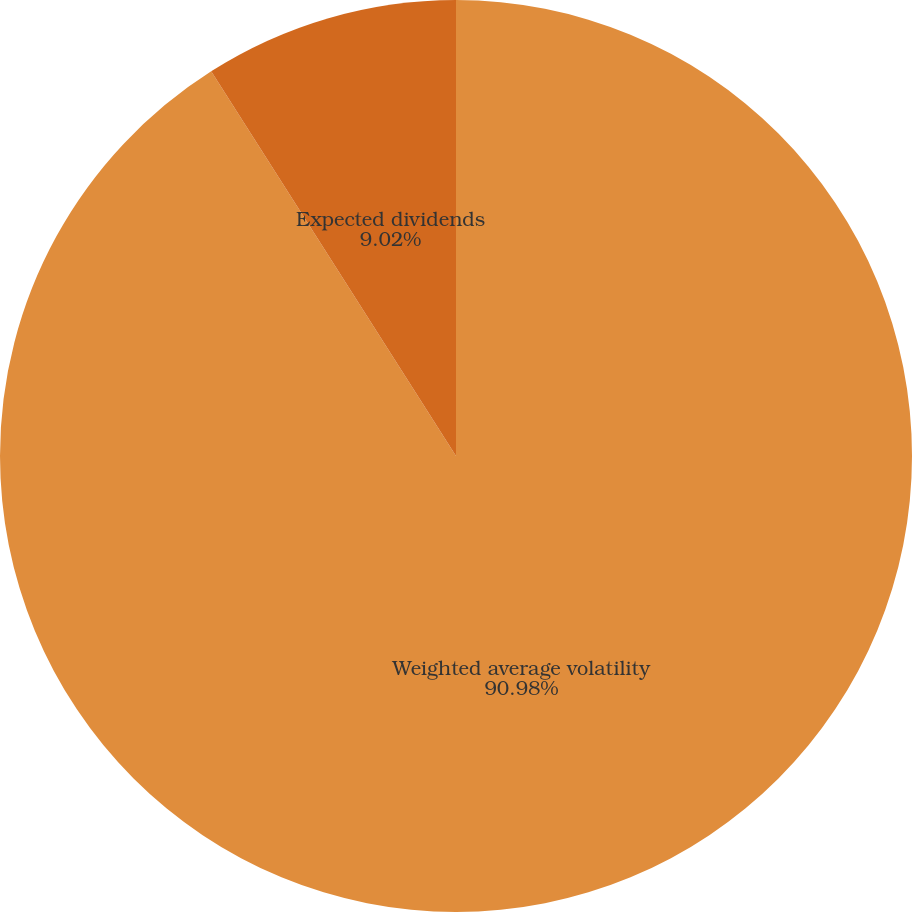<chart> <loc_0><loc_0><loc_500><loc_500><pie_chart><fcel>Weighted average volatility<fcel>Expected dividends<nl><fcel>90.98%<fcel>9.02%<nl></chart> 